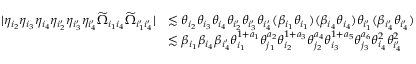<formula> <loc_0><loc_0><loc_500><loc_500>\begin{array} { r l } { | \eta _ { i _ { 2 } } \eta _ { i _ { 3 } } \eta _ { i _ { 4 } } \eta _ { i _ { 2 } ^ { \prime } } \eta _ { i _ { 3 } ^ { \prime } } \eta _ { i _ { 4 } ^ { \prime } } \widetilde { \Omega } _ { i _ { 1 } i _ { 4 } } \widetilde { \Omega } _ { i _ { 1 } ^ { \prime } i _ { 4 } ^ { \prime } } | } & { \lesssim \theta _ { i _ { 2 } } \theta _ { i _ { 3 } } \theta _ { i _ { 4 } } \theta _ { i _ { 2 } ^ { \prime } } \theta _ { i _ { 3 } ^ { \prime } } \theta _ { i _ { 4 } ^ { \prime } } ( \beta _ { i _ { 1 } } \theta _ { i _ { 1 } } ) ( \beta _ { i _ { 4 } } \theta _ { i _ { 4 } } ) \theta _ { i _ { 1 } ^ { \prime } } ( \beta _ { i _ { 4 } ^ { \prime } } \theta _ { i _ { 4 } ^ { \prime } } ) } \\ & { \lesssim \beta _ { i _ { 1 } } \beta _ { i _ { 4 } } \beta _ { i _ { 4 } ^ { \prime } } \theta _ { i _ { 1 } } ^ { 1 + a _ { 1 } } \theta _ { j _ { 1 } } ^ { a _ { 2 } } \theta _ { i _ { 2 } } ^ { 1 + a _ { 3 } } \theta _ { j _ { 2 } } ^ { a _ { 4 } } \theta _ { i _ { 3 } } ^ { 1 + a _ { 5 } } \theta _ { j _ { 3 } } ^ { a _ { 6 } } \theta _ { i _ { 4 } } ^ { 2 } \theta _ { i _ { 4 } ^ { \prime } } ^ { 2 } } \end{array}</formula> 